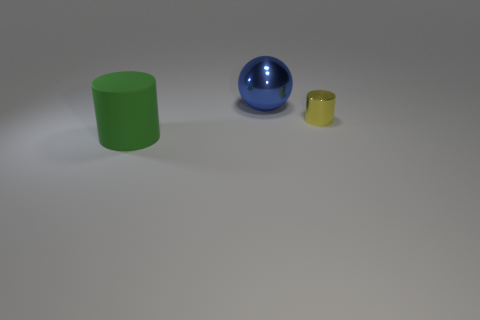Add 2 small yellow things. How many objects exist? 5 Subtract all cylinders. How many objects are left? 1 Subtract all tiny cylinders. Subtract all large blue things. How many objects are left? 1 Add 1 cylinders. How many cylinders are left? 3 Add 1 metallic things. How many metallic things exist? 3 Subtract 0 brown cylinders. How many objects are left? 3 